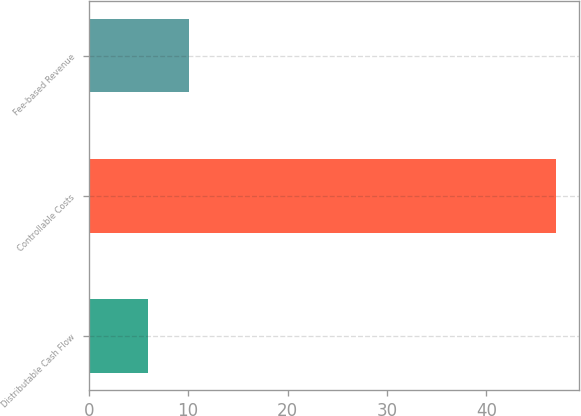<chart> <loc_0><loc_0><loc_500><loc_500><bar_chart><fcel>Distributable Cash Flow<fcel>Controllable Costs<fcel>Fee-based Revenue<nl><fcel>6<fcel>47<fcel>10.1<nl></chart> 